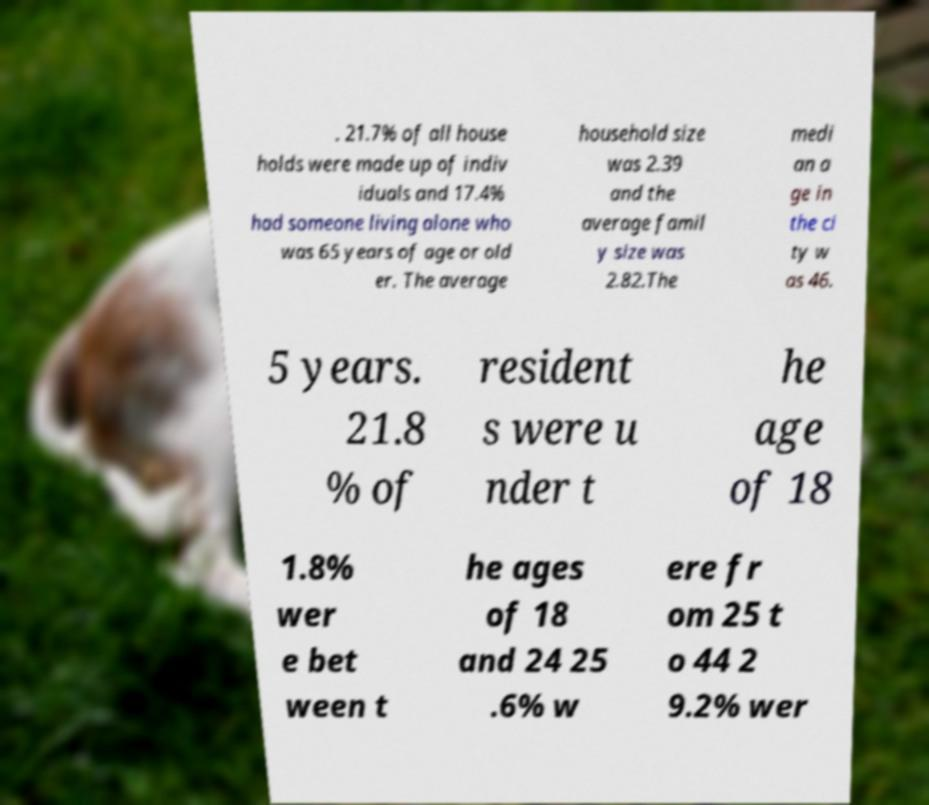What messages or text are displayed in this image? I need them in a readable, typed format. . 21.7% of all house holds were made up of indiv iduals and 17.4% had someone living alone who was 65 years of age or old er. The average household size was 2.39 and the average famil y size was 2.82.The medi an a ge in the ci ty w as 46. 5 years. 21.8 % of resident s were u nder t he age of 18 1.8% wer e bet ween t he ages of 18 and 24 25 .6% w ere fr om 25 t o 44 2 9.2% wer 